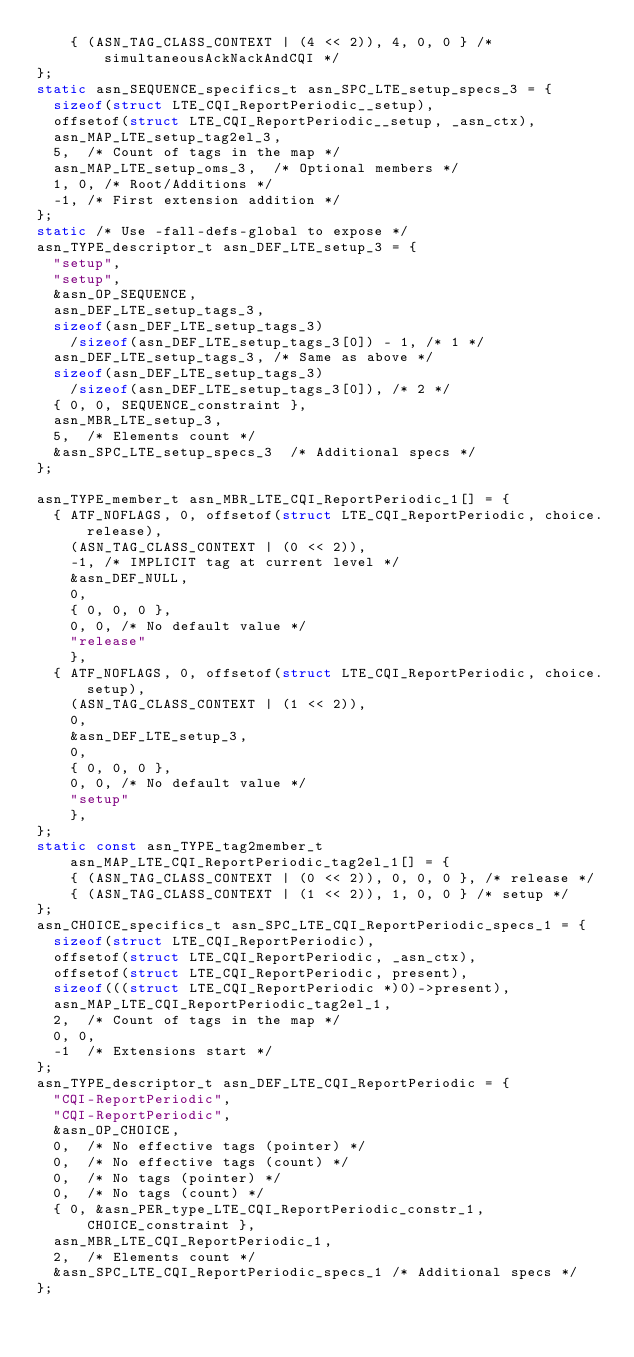<code> <loc_0><loc_0><loc_500><loc_500><_C_>    { (ASN_TAG_CLASS_CONTEXT | (4 << 2)), 4, 0, 0 } /* simultaneousAckNackAndCQI */
};
static asn_SEQUENCE_specifics_t asn_SPC_LTE_setup_specs_3 = {
	sizeof(struct LTE_CQI_ReportPeriodic__setup),
	offsetof(struct LTE_CQI_ReportPeriodic__setup, _asn_ctx),
	asn_MAP_LTE_setup_tag2el_3,
	5,	/* Count of tags in the map */
	asn_MAP_LTE_setup_oms_3,	/* Optional members */
	1, 0,	/* Root/Additions */
	-1,	/* First extension addition */
};
static /* Use -fall-defs-global to expose */
asn_TYPE_descriptor_t asn_DEF_LTE_setup_3 = {
	"setup",
	"setup",
	&asn_OP_SEQUENCE,
	asn_DEF_LTE_setup_tags_3,
	sizeof(asn_DEF_LTE_setup_tags_3)
		/sizeof(asn_DEF_LTE_setup_tags_3[0]) - 1, /* 1 */
	asn_DEF_LTE_setup_tags_3,	/* Same as above */
	sizeof(asn_DEF_LTE_setup_tags_3)
		/sizeof(asn_DEF_LTE_setup_tags_3[0]), /* 2 */
	{ 0, 0, SEQUENCE_constraint },
	asn_MBR_LTE_setup_3,
	5,	/* Elements count */
	&asn_SPC_LTE_setup_specs_3	/* Additional specs */
};

asn_TYPE_member_t asn_MBR_LTE_CQI_ReportPeriodic_1[] = {
	{ ATF_NOFLAGS, 0, offsetof(struct LTE_CQI_ReportPeriodic, choice.release),
		(ASN_TAG_CLASS_CONTEXT | (0 << 2)),
		-1,	/* IMPLICIT tag at current level */
		&asn_DEF_NULL,
		0,
		{ 0, 0, 0 },
		0, 0, /* No default value */
		"release"
		},
	{ ATF_NOFLAGS, 0, offsetof(struct LTE_CQI_ReportPeriodic, choice.setup),
		(ASN_TAG_CLASS_CONTEXT | (1 << 2)),
		0,
		&asn_DEF_LTE_setup_3,
		0,
		{ 0, 0, 0 },
		0, 0, /* No default value */
		"setup"
		},
};
static const asn_TYPE_tag2member_t asn_MAP_LTE_CQI_ReportPeriodic_tag2el_1[] = {
    { (ASN_TAG_CLASS_CONTEXT | (0 << 2)), 0, 0, 0 }, /* release */
    { (ASN_TAG_CLASS_CONTEXT | (1 << 2)), 1, 0, 0 } /* setup */
};
asn_CHOICE_specifics_t asn_SPC_LTE_CQI_ReportPeriodic_specs_1 = {
	sizeof(struct LTE_CQI_ReportPeriodic),
	offsetof(struct LTE_CQI_ReportPeriodic, _asn_ctx),
	offsetof(struct LTE_CQI_ReportPeriodic, present),
	sizeof(((struct LTE_CQI_ReportPeriodic *)0)->present),
	asn_MAP_LTE_CQI_ReportPeriodic_tag2el_1,
	2,	/* Count of tags in the map */
	0, 0,
	-1	/* Extensions start */
};
asn_TYPE_descriptor_t asn_DEF_LTE_CQI_ReportPeriodic = {
	"CQI-ReportPeriodic",
	"CQI-ReportPeriodic",
	&asn_OP_CHOICE,
	0,	/* No effective tags (pointer) */
	0,	/* No effective tags (count) */
	0,	/* No tags (pointer) */
	0,	/* No tags (count) */
	{ 0, &asn_PER_type_LTE_CQI_ReportPeriodic_constr_1, CHOICE_constraint },
	asn_MBR_LTE_CQI_ReportPeriodic_1,
	2,	/* Elements count */
	&asn_SPC_LTE_CQI_ReportPeriodic_specs_1	/* Additional specs */
};

</code> 